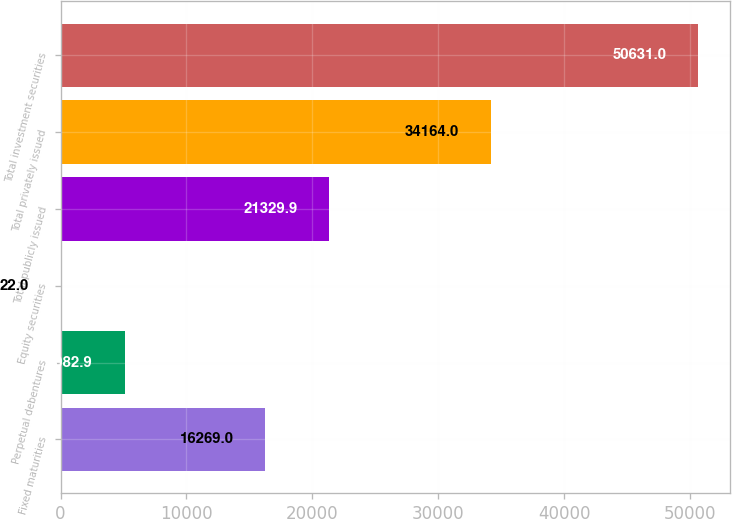Convert chart to OTSL. <chart><loc_0><loc_0><loc_500><loc_500><bar_chart><fcel>Fixed maturities<fcel>Perpetual debentures<fcel>Equity securities<fcel>Total publicly issued<fcel>Total privately issued<fcel>Total investment securities<nl><fcel>16269<fcel>5082.9<fcel>22<fcel>21329.9<fcel>34164<fcel>50631<nl></chart> 